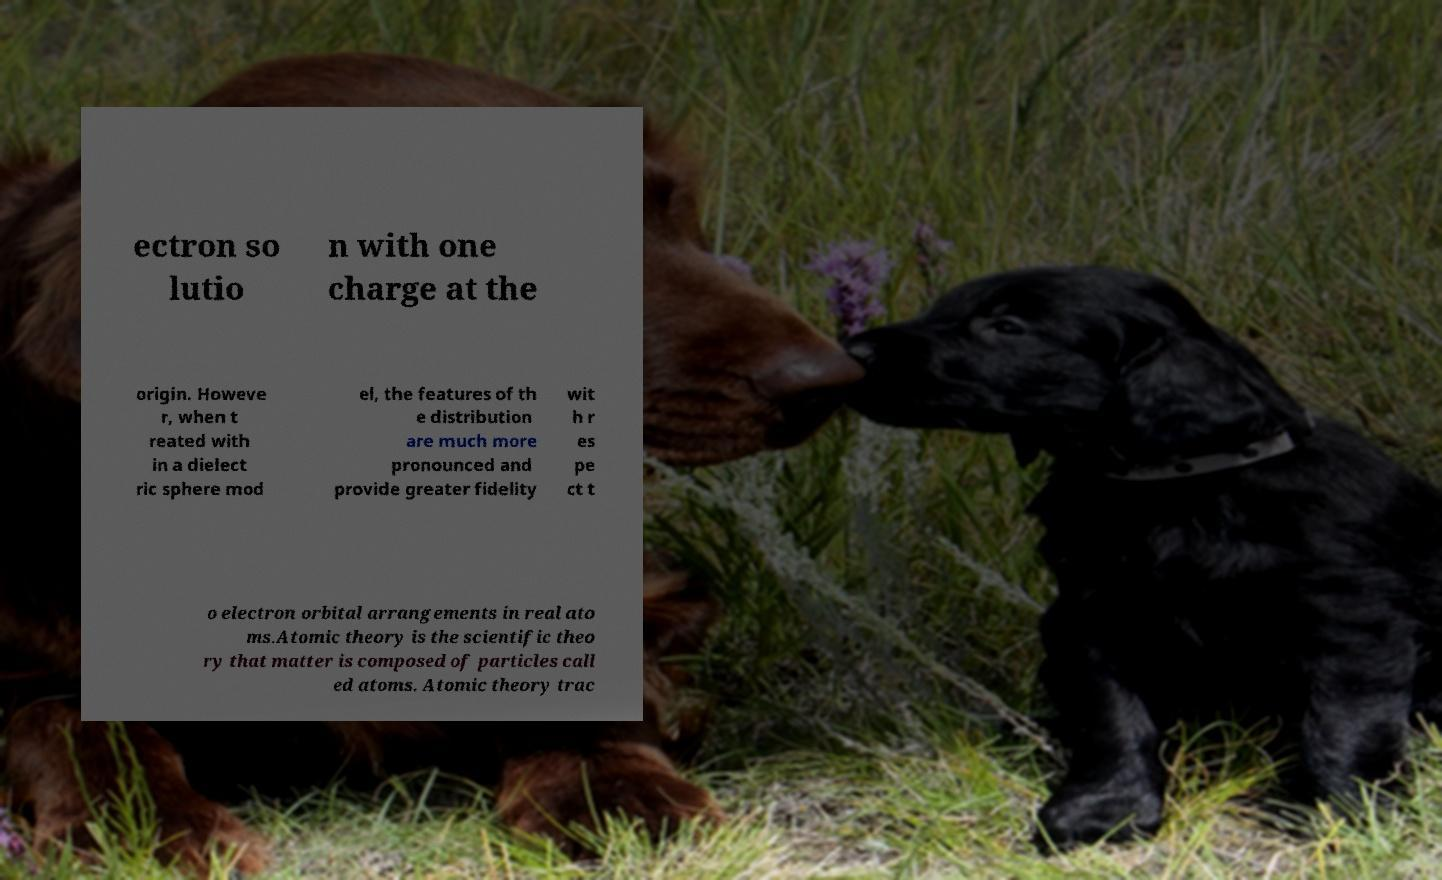Could you assist in decoding the text presented in this image and type it out clearly? ectron so lutio n with one charge at the origin. Howeve r, when t reated with in a dielect ric sphere mod el, the features of th e distribution are much more pronounced and provide greater fidelity wit h r es pe ct t o electron orbital arrangements in real ato ms.Atomic theory is the scientific theo ry that matter is composed of particles call ed atoms. Atomic theory trac 